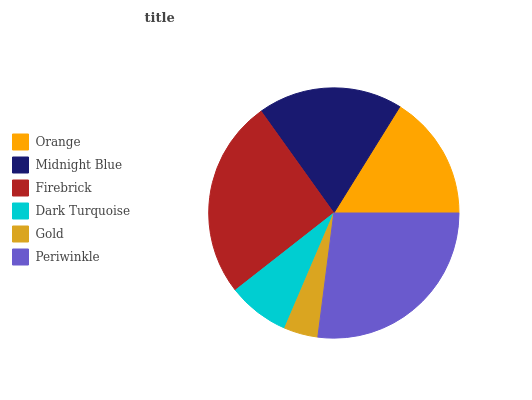Is Gold the minimum?
Answer yes or no. Yes. Is Periwinkle the maximum?
Answer yes or no. Yes. Is Midnight Blue the minimum?
Answer yes or no. No. Is Midnight Blue the maximum?
Answer yes or no. No. Is Midnight Blue greater than Orange?
Answer yes or no. Yes. Is Orange less than Midnight Blue?
Answer yes or no. Yes. Is Orange greater than Midnight Blue?
Answer yes or no. No. Is Midnight Blue less than Orange?
Answer yes or no. No. Is Midnight Blue the high median?
Answer yes or no. Yes. Is Orange the low median?
Answer yes or no. Yes. Is Gold the high median?
Answer yes or no. No. Is Gold the low median?
Answer yes or no. No. 